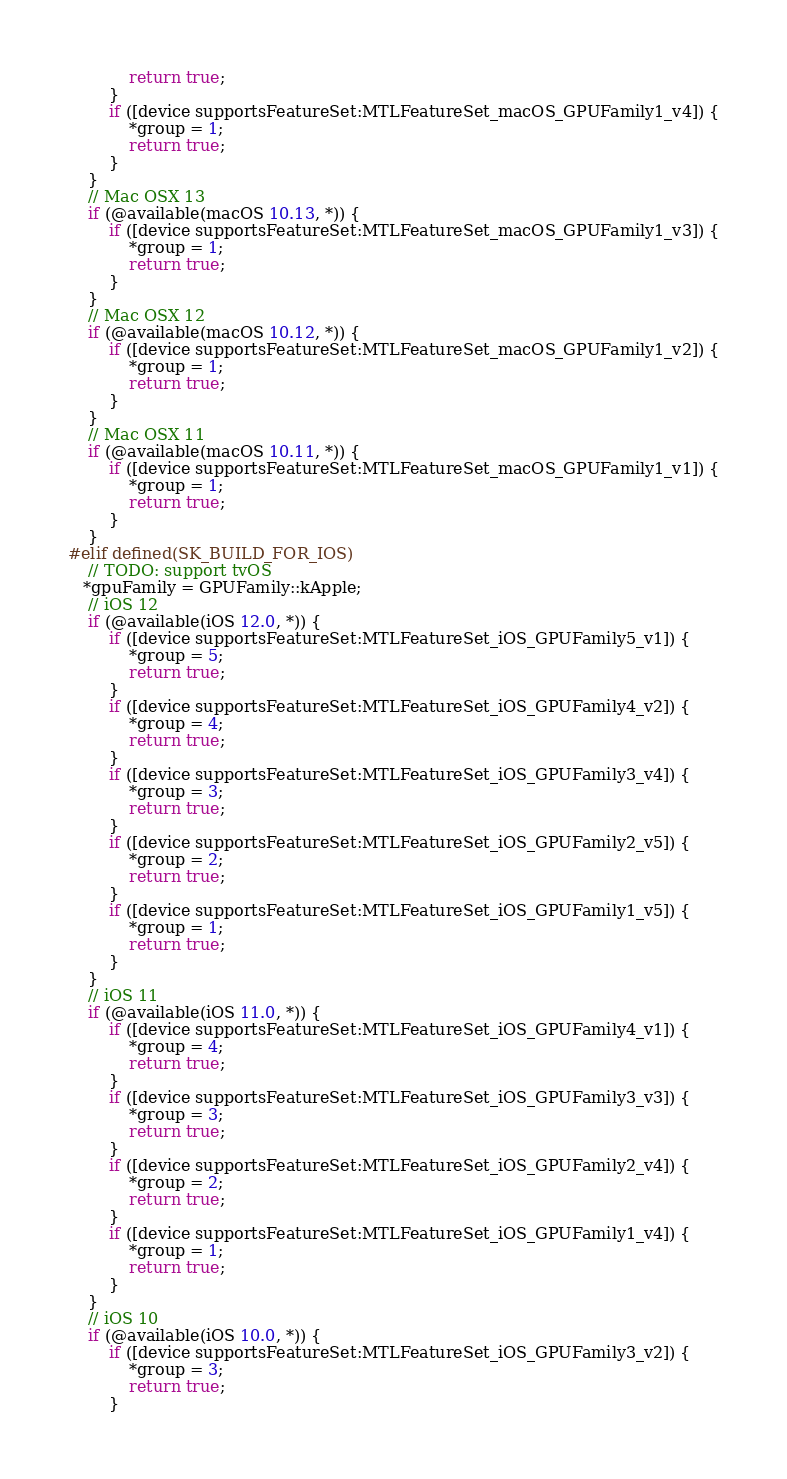Convert code to text. <code><loc_0><loc_0><loc_500><loc_500><_ObjectiveC_>            return true;
        }
        if ([device supportsFeatureSet:MTLFeatureSet_macOS_GPUFamily1_v4]) {
            *group = 1;
            return true;
        }
    }
    // Mac OSX 13
    if (@available(macOS 10.13, *)) {
        if ([device supportsFeatureSet:MTLFeatureSet_macOS_GPUFamily1_v3]) {
            *group = 1;
            return true;
        }
    }
    // Mac OSX 12
    if (@available(macOS 10.12, *)) {
        if ([device supportsFeatureSet:MTLFeatureSet_macOS_GPUFamily1_v2]) {
            *group = 1;
            return true;
        }
    }
    // Mac OSX 11
    if (@available(macOS 10.11, *)) {
        if ([device supportsFeatureSet:MTLFeatureSet_macOS_GPUFamily1_v1]) {
            *group = 1;
            return true;
        }
    }
#elif defined(SK_BUILD_FOR_IOS)
    // TODO: support tvOS
   *gpuFamily = GPUFamily::kApple;
    // iOS 12
    if (@available(iOS 12.0, *)) {
        if ([device supportsFeatureSet:MTLFeatureSet_iOS_GPUFamily5_v1]) {
            *group = 5;
            return true;
        }
        if ([device supportsFeatureSet:MTLFeatureSet_iOS_GPUFamily4_v2]) {
            *group = 4;
            return true;
        }
        if ([device supportsFeatureSet:MTLFeatureSet_iOS_GPUFamily3_v4]) {
            *group = 3;
            return true;
        }
        if ([device supportsFeatureSet:MTLFeatureSet_iOS_GPUFamily2_v5]) {
            *group = 2;
            return true;
        }
        if ([device supportsFeatureSet:MTLFeatureSet_iOS_GPUFamily1_v5]) {
            *group = 1;
            return true;
        }
    }
    // iOS 11
    if (@available(iOS 11.0, *)) {
        if ([device supportsFeatureSet:MTLFeatureSet_iOS_GPUFamily4_v1]) {
            *group = 4;
            return true;
        }
        if ([device supportsFeatureSet:MTLFeatureSet_iOS_GPUFamily3_v3]) {
            *group = 3;
            return true;
        }
        if ([device supportsFeatureSet:MTLFeatureSet_iOS_GPUFamily2_v4]) {
            *group = 2;
            return true;
        }
        if ([device supportsFeatureSet:MTLFeatureSet_iOS_GPUFamily1_v4]) {
            *group = 1;
            return true;
        }
    }
    // iOS 10
    if (@available(iOS 10.0, *)) {
        if ([device supportsFeatureSet:MTLFeatureSet_iOS_GPUFamily3_v2]) {
            *group = 3;
            return true;
        }</code> 